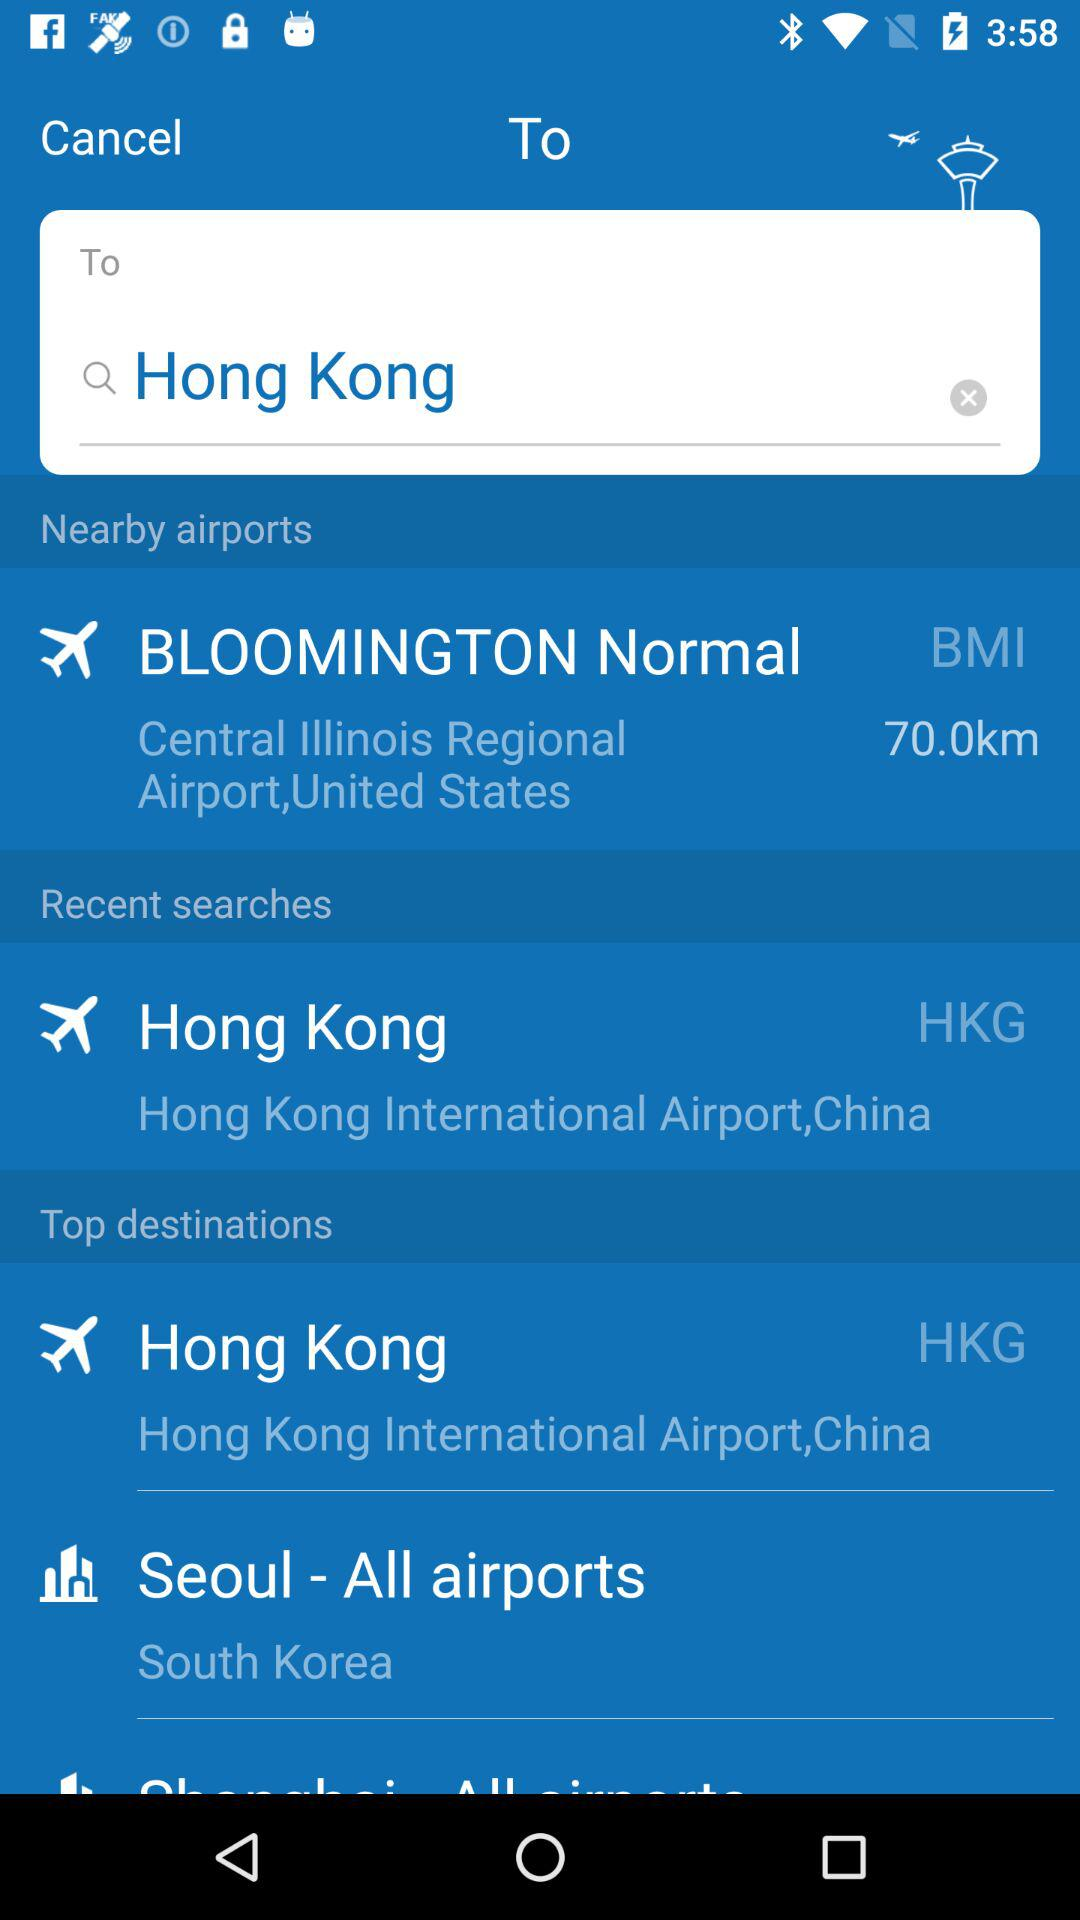What is the distance to BMI Airport? The distance is 70 kilometers. 